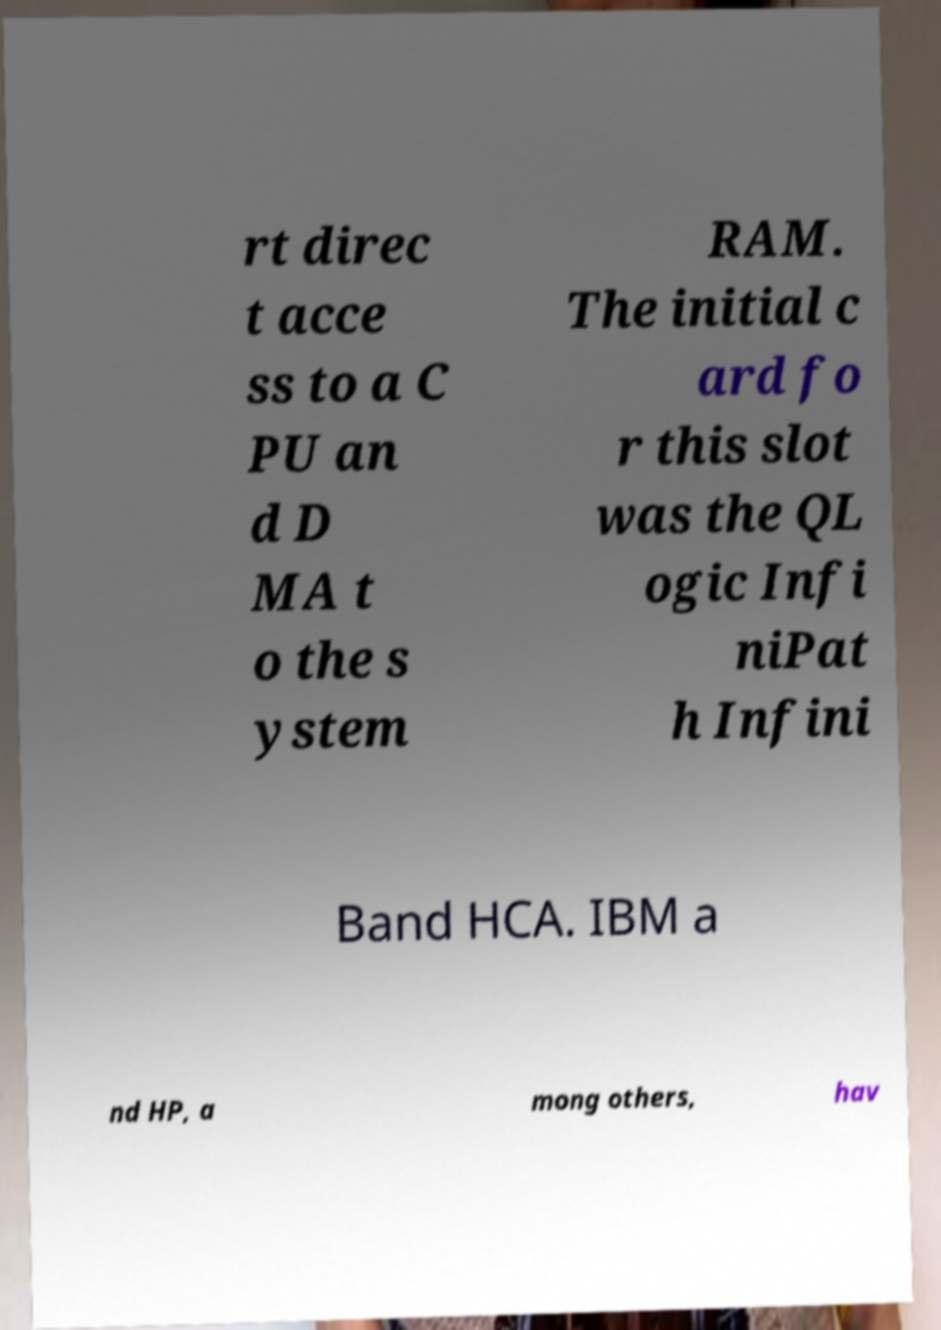There's text embedded in this image that I need extracted. Can you transcribe it verbatim? rt direc t acce ss to a C PU an d D MA t o the s ystem RAM. The initial c ard fo r this slot was the QL ogic Infi niPat h Infini Band HCA. IBM a nd HP, a mong others, hav 